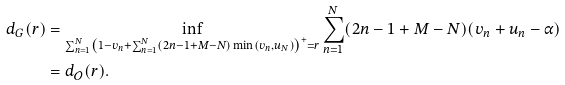<formula> <loc_0><loc_0><loc_500><loc_500>d _ { G } ( r ) & = \inf _ { \sum _ { n = 1 } ^ { N } \left ( 1 - v _ { n } + \sum _ { n = 1 } ^ { N } ( 2 n - 1 + M - N ) \min ( v _ { n } , u _ { N } ) \right ) ^ { + } = r } \sum _ { n = 1 } ^ { N } ( 2 n - 1 + M - N ) ( v _ { n } + u _ { n } - \alpha ) \\ & = d _ { \mathcal { O } } ( r ) .</formula> 